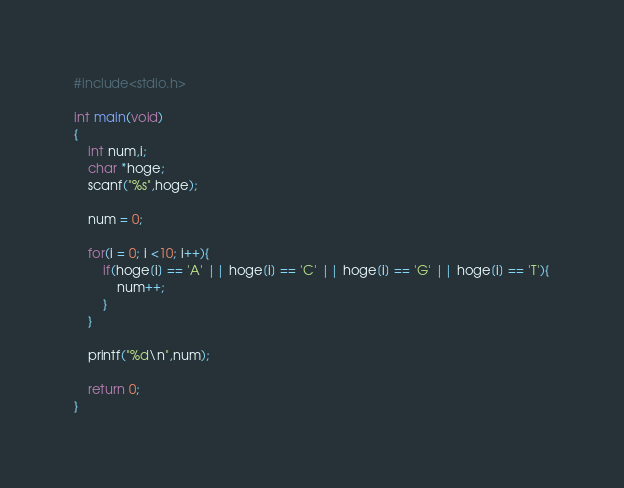<code> <loc_0><loc_0><loc_500><loc_500><_C_>#include<stdio.h>

int main(void)
{
	int num,i;
	char *hoge;
	scanf("%s",hoge);
	
	num = 0;
	
	for(i = 0; i <10; i++){
		if(hoge[i] == 'A' || hoge[i] == 'C' || hoge[i] == 'G' || hoge[i] == 'T'){
			num++;
		}
	}
	
	printf("%d\n",num);
	
	return 0;
}</code> 